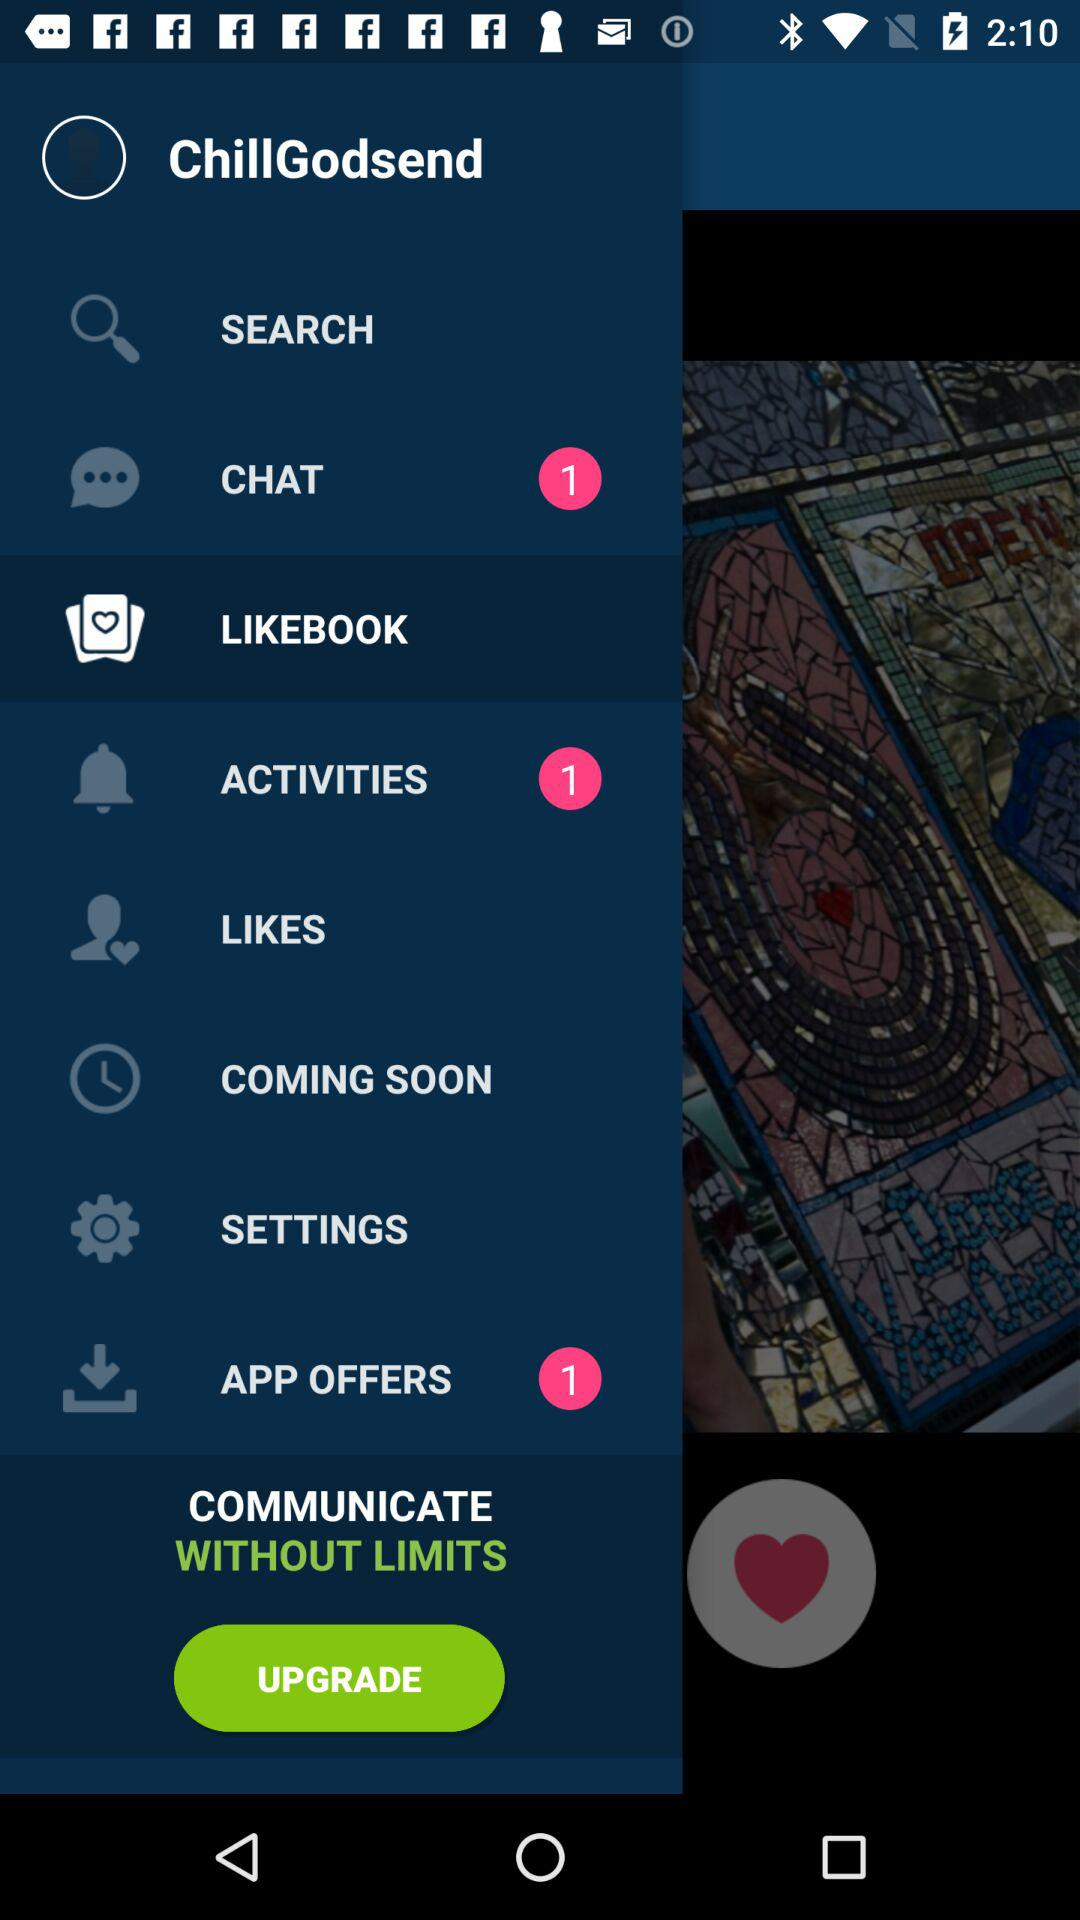What's the user name? The user name is Chill Godsend. 